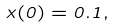Convert formula to latex. <formula><loc_0><loc_0><loc_500><loc_500>x ( 0 ) = 0 . 1 ,</formula> 